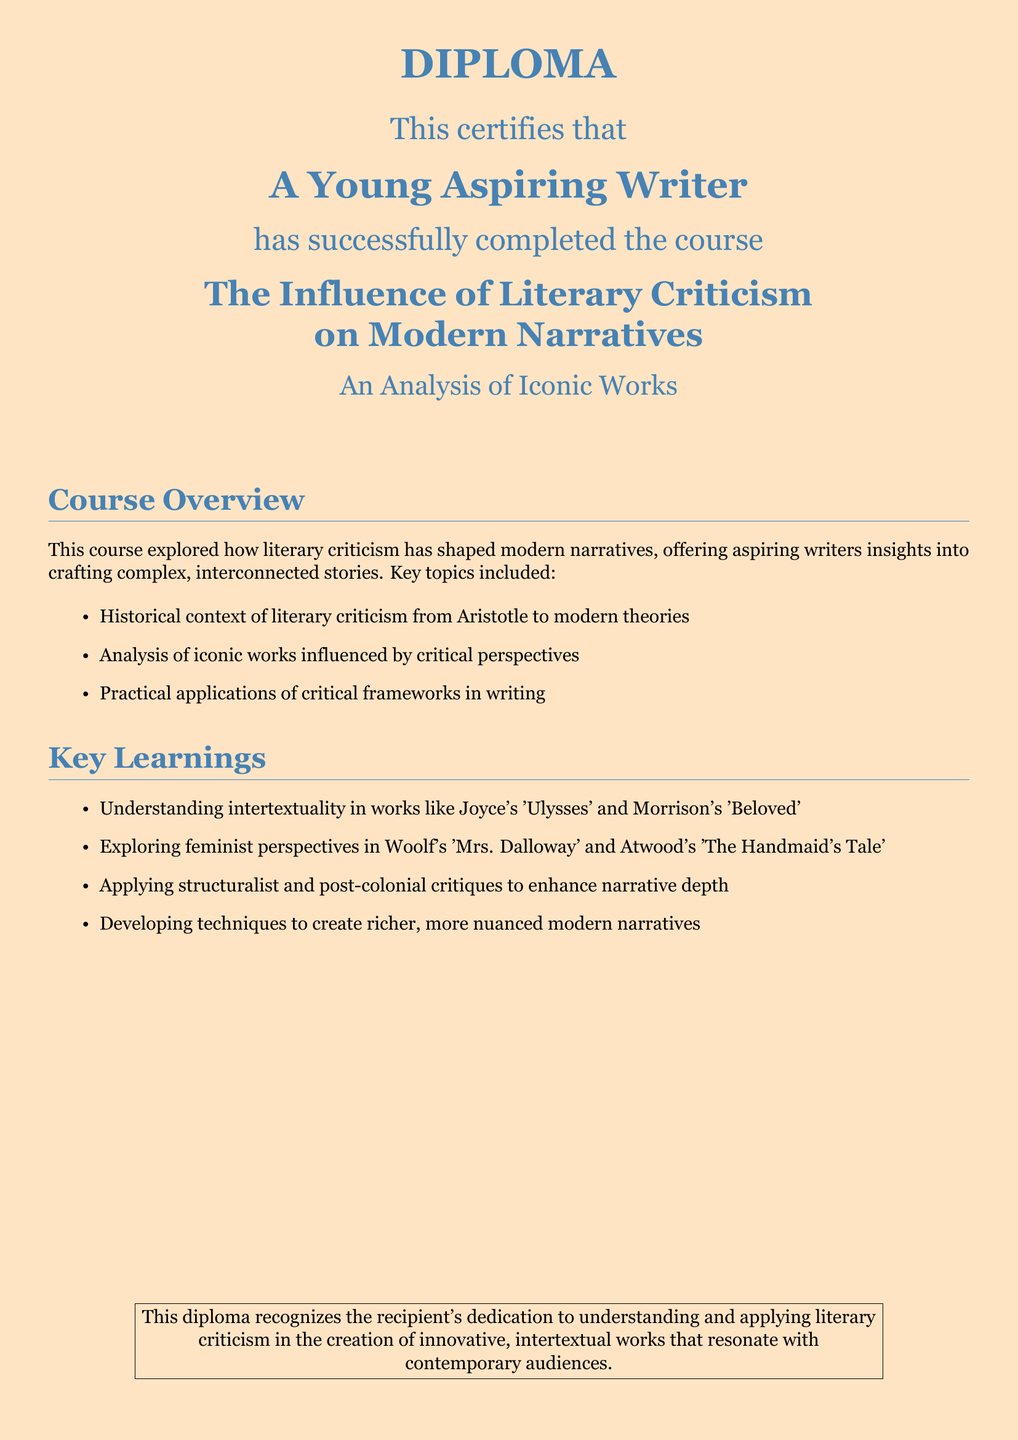what is the main title of the diploma? The main title is stated prominently in the document, which is "DIPLOMA."
Answer: DIPLOMA who completed the course? The name of the recipient is specified in the document, which is "A Young Aspiring Writer."
Answer: A Young Aspiring Writer what is the course title? The course title is explicitly provided in the diploma, which includes the influence of literary criticism on narratives.
Answer: The Influence of Literary Criticism on Modern Narratives how many key learnings are listed? The document contains a list of key learnings under specific points, amounting to four main items.
Answer: 4 which iconic work by Morrison is mentioned? The icon credited to Morrison within the key learnings is specified, which is "Beloved."
Answer: Beloved which critical perspective is explored in Woolf's work? The document specifies that feminist perspectives are explored in relation to Woolf's work.
Answer: feminist perspectives what historical figure is mentioned in the context of literary criticism? The document references Aristotle as a historical figure in the context of literary criticism.
Answer: Aristotle what color is used for the page background? The document specifies the page color used throughout the diploma.
Answer: light peach what is the purpose of this diploma? The purpose is to recognize the recipient's dedication to a particular area of literary study and application.
Answer: to understand and apply literary criticism 